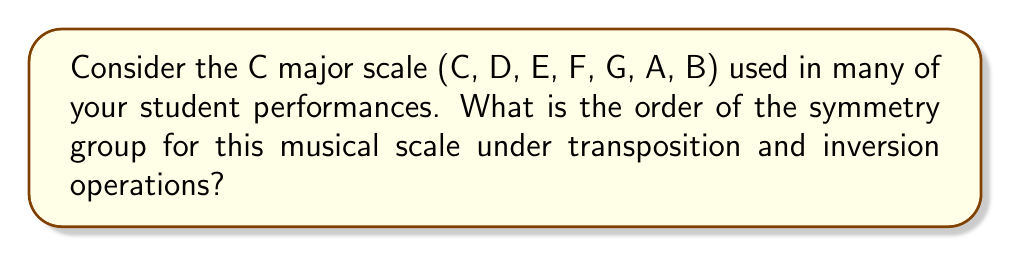Provide a solution to this math problem. To determine the symmetry group of the C major scale, we need to consider the operations that preserve its structure:

1. Transpositions: There are 12 possible transpositions (including the identity) in the chromatic scale.
   However, only 7 of these transpositions map the C major scale onto itself:
   $T_0, T_2, T_4, T_5, T_7, T_9, T_{11}$

2. Inversions: There are also 12 possible inversions.
   However, only 7 of these inversions map the C major scale onto itself:
   $I_0, I_2, I_4, I_5, I_7, I_9, I_{11}$

3. The total number of symmetry operations is the sum of these transpositions and inversions:
   $7 + 7 = 14$

4. These 14 operations form a group under composition, known as the dihedral group $D_7$.

5. The order of a group is the number of elements in the group.

Therefore, the order of the symmetry group for the C major scale is 14.

This group structure reflects the musical properties of the scale:
- The 7 transpositions correspond to the 7 modes of the major scale.
- The 7 inversions correspond to the "mirror" transformations of these modes.

Understanding this symmetry can help in composing and arranging music for your student showcases, as it reveals fundamental relationships between different musical patterns within the scale.
Answer: 14 